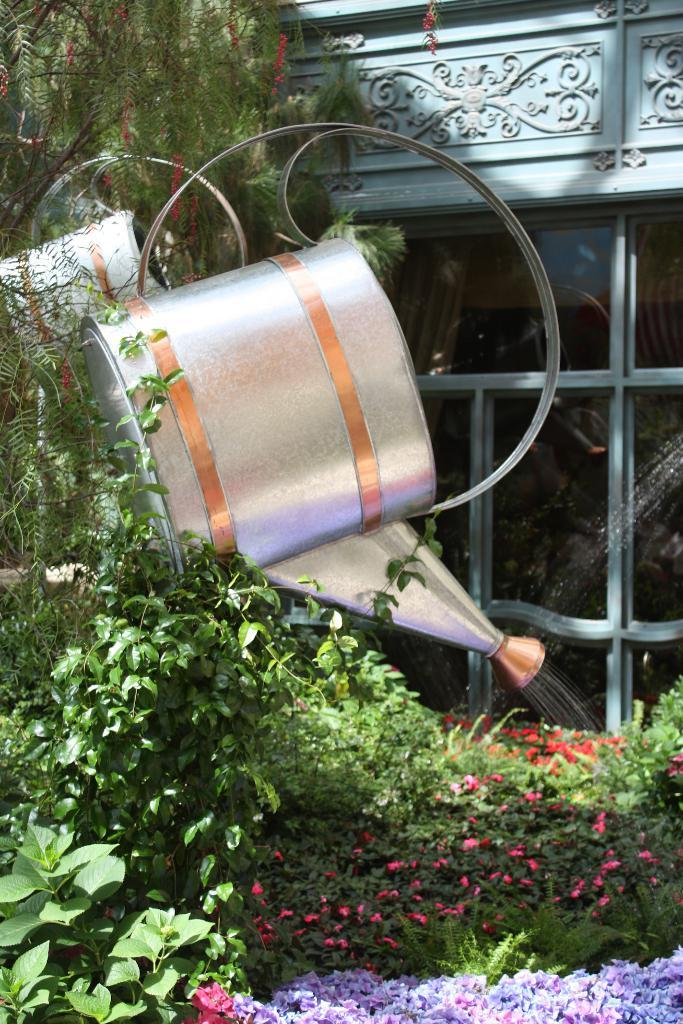What object is present in the image for watering plants? There is a water can in the image for watering plants. What type of vegetation can be seen in the image? There are plants and flowers in the image. What feature allows a view of the outdoors while indoors? There is a glass door in the image that provides a view of the outdoors. What type of leather can be seen on the plants in the image? There is no leather present on the plants in the image; they are covered with leaves and flowers. How many fowl are visible in the image? There are no fowl present in the image; it features a water can, plants, flowers, and a glass door. 